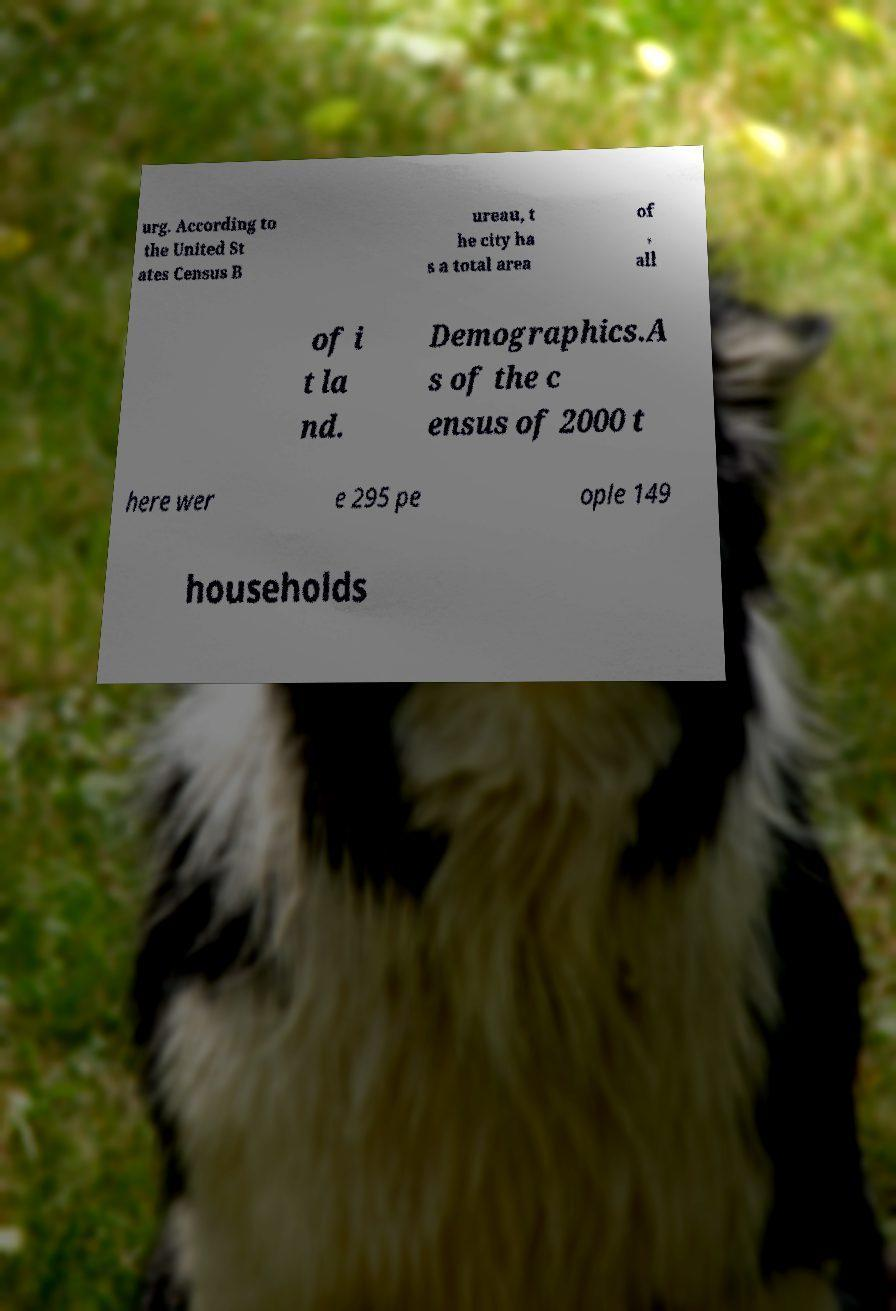Please read and relay the text visible in this image. What does it say? urg. According to the United St ates Census B ureau, t he city ha s a total area of , all of i t la nd. Demographics.A s of the c ensus of 2000 t here wer e 295 pe ople 149 households 